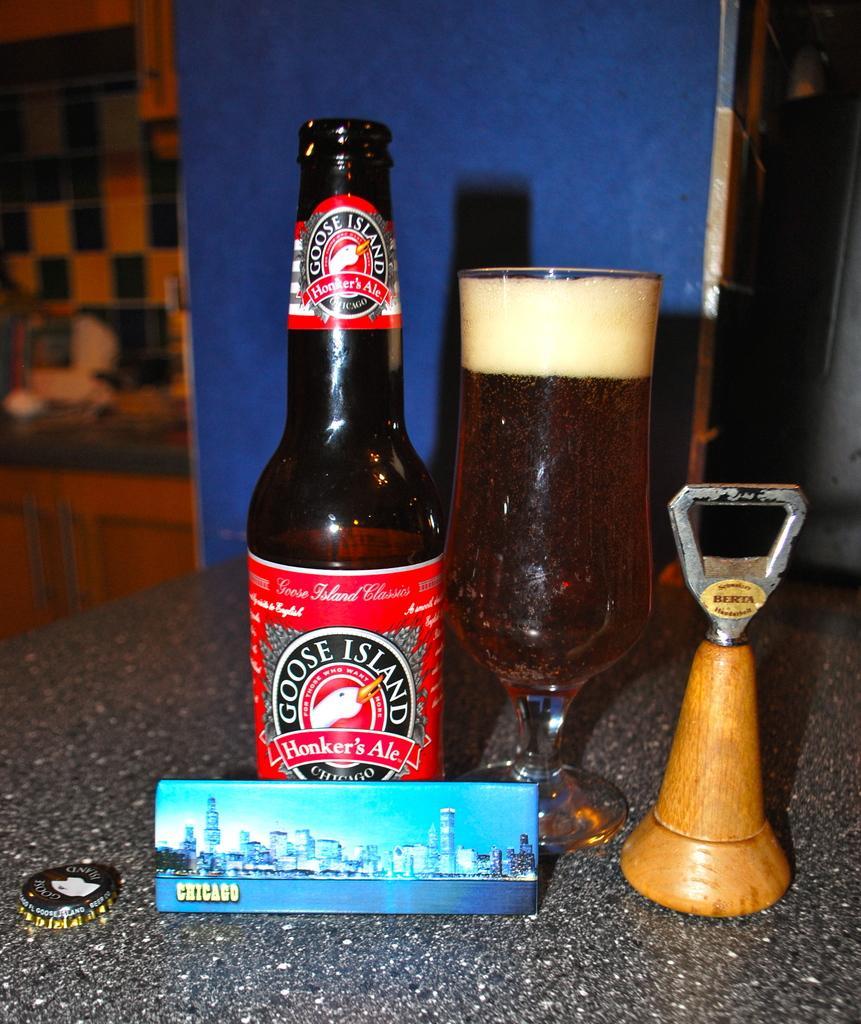Can you describe this image briefly? Here in this picture we can see a bottle a glass filled with alcohol and a opener and a card present on the table over there and we can also see the cap of the bottle over there. 